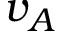Convert formula to latex. <formula><loc_0><loc_0><loc_500><loc_500>v _ { A }</formula> 